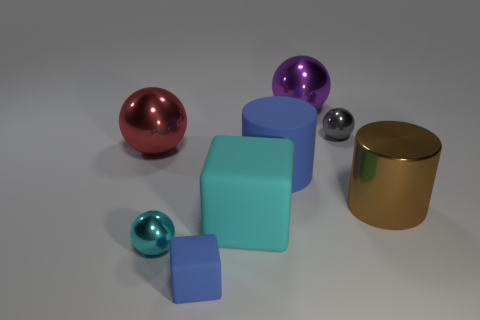Add 2 large blue rubber things. How many objects exist? 10 Subtract all cylinders. How many objects are left? 6 Add 6 tiny shiny spheres. How many tiny shiny spheres are left? 8 Add 1 spheres. How many spheres exist? 5 Subtract 0 yellow spheres. How many objects are left? 8 Subtract all large rubber objects. Subtract all purple metallic spheres. How many objects are left? 5 